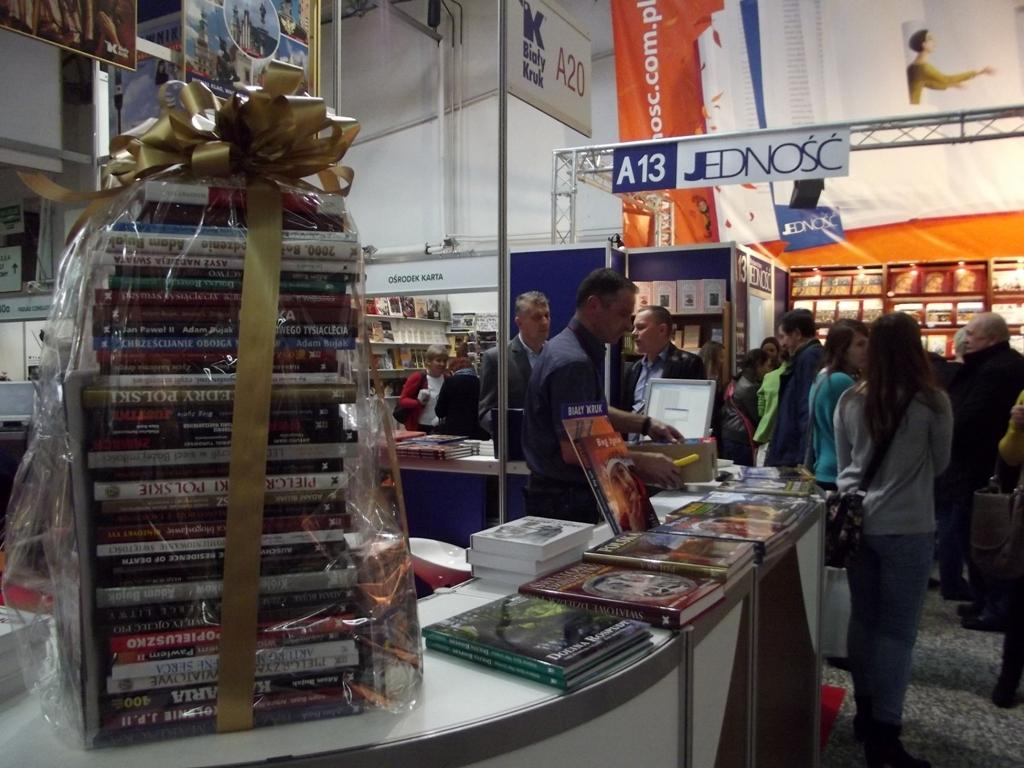Provide a one-sentence caption for the provided image. Display at a sales event to sell dvd next to a sign reading A13 Jednosc. 